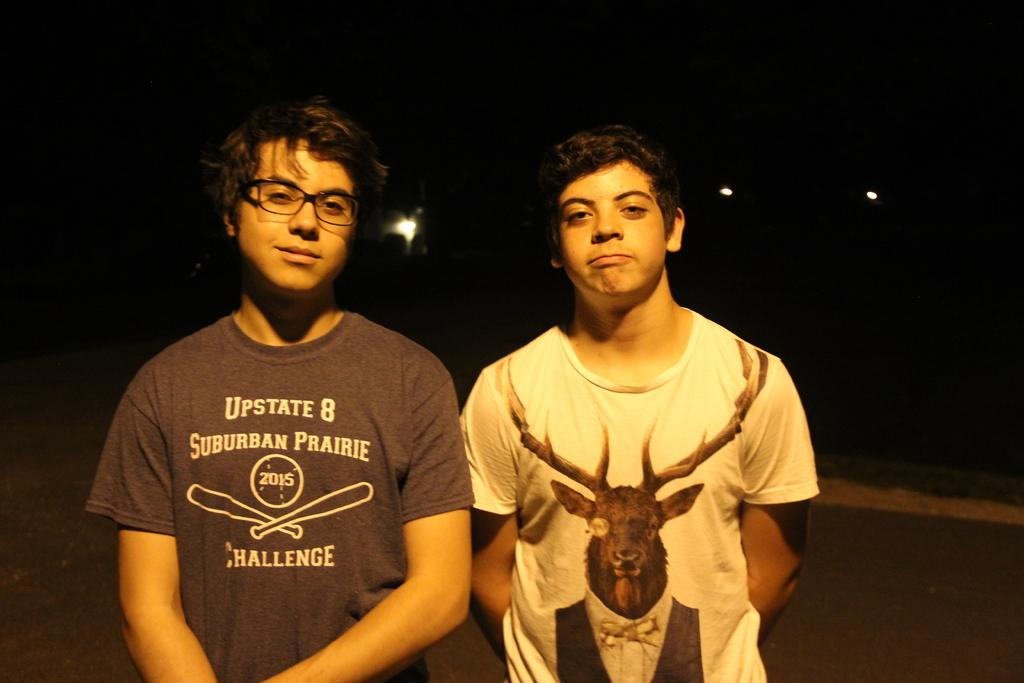How many people are in the image? There are two men standing in the image. What is the facial expression of the men in the image? The men are smiling. What type of clothing are the men wearing? The men are wearing T-shirts. Can you describe the lighting in the image? It is uncertain if there are lights in the image. How would you describe the background of the image? The background of the image appears dark. What type of brake can be seen in the image? There is no brake present in the image. What is being served for dinner in the image? There is no dinner or food visible in the image. 